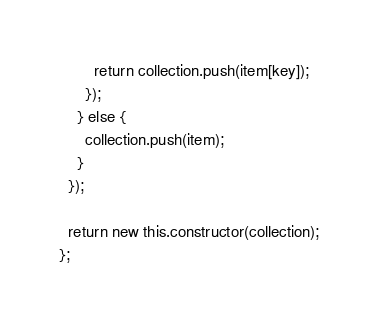Convert code to text. <code><loc_0><loc_0><loc_500><loc_500><_JavaScript_>        return collection.push(item[key]);
      });
    } else {
      collection.push(item);
    }
  });

  return new this.constructor(collection);
};</code> 